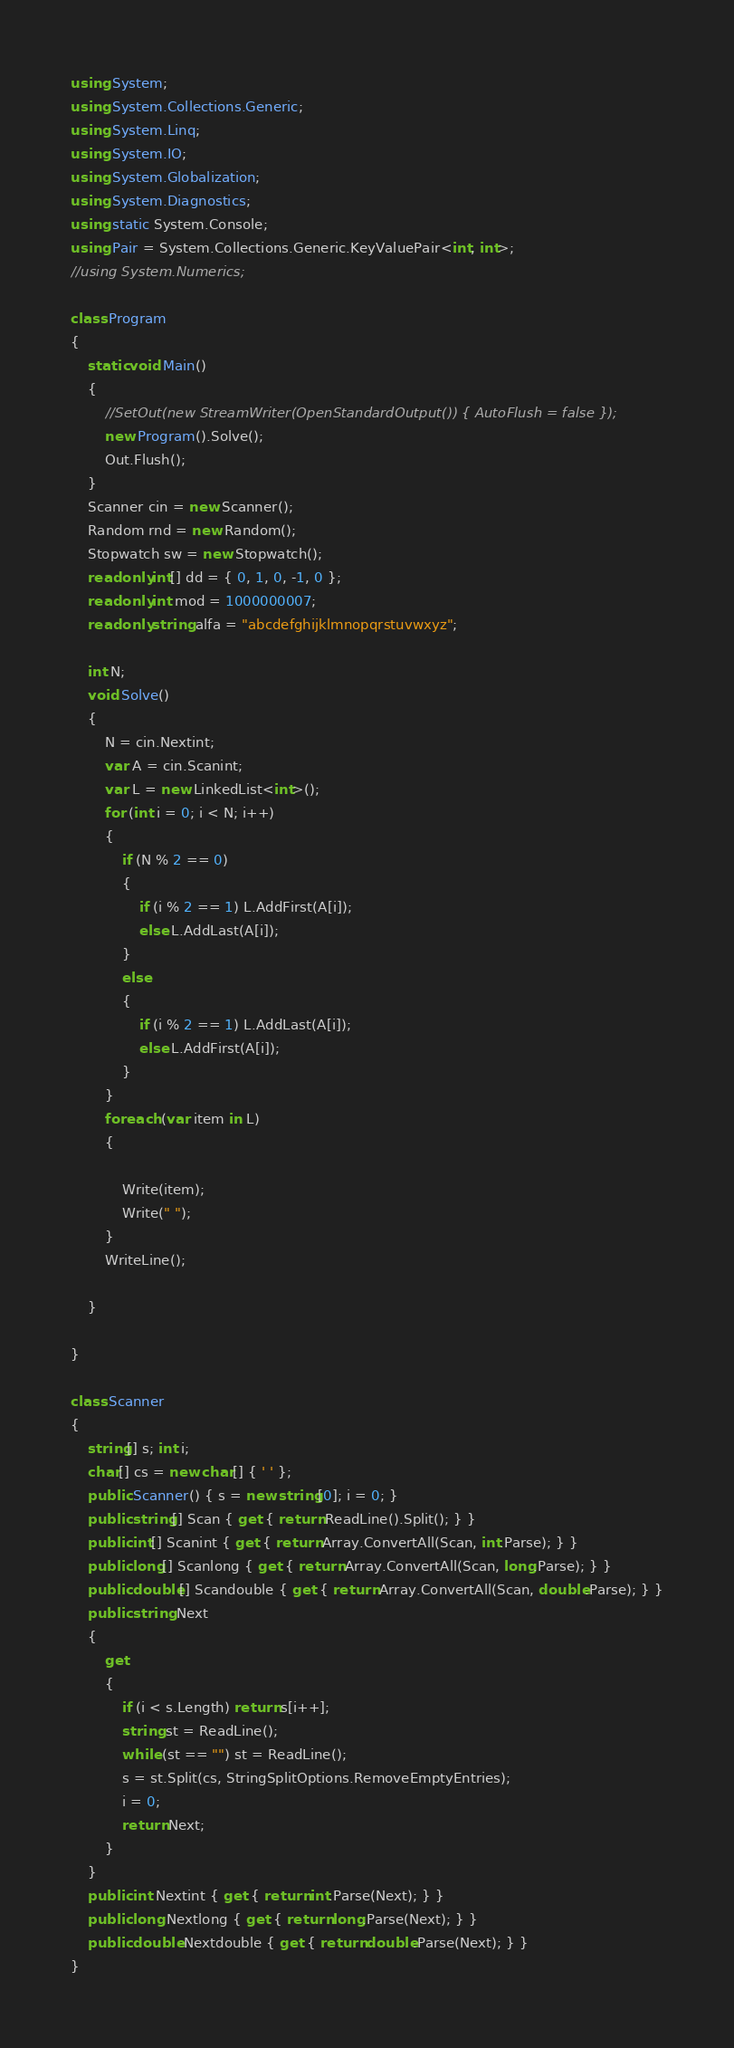Convert code to text. <code><loc_0><loc_0><loc_500><loc_500><_C#_>using System;
using System.Collections.Generic;
using System.Linq;
using System.IO;
using System.Globalization;
using System.Diagnostics;
using static System.Console;
using Pair = System.Collections.Generic.KeyValuePair<int, int>;
//using System.Numerics;

class Program
{
    static void Main()
    {
        //SetOut(new StreamWriter(OpenStandardOutput()) { AutoFlush = false });
        new Program().Solve();
        Out.Flush();
    }
    Scanner cin = new Scanner();
    Random rnd = new Random();
    Stopwatch sw = new Stopwatch();
    readonly int[] dd = { 0, 1, 0, -1, 0 };
    readonly int mod = 1000000007;
    readonly string alfa = "abcdefghijklmnopqrstuvwxyz";

    int N;
    void Solve()
    {
        N = cin.Nextint;
        var A = cin.Scanint;
        var L = new LinkedList<int>();
        for (int i = 0; i < N; i++)
        {
            if (N % 2 == 0)
            {
                if (i % 2 == 1) L.AddFirst(A[i]);
                else L.AddLast(A[i]);
            }
            else
            {
                if (i % 2 == 1) L.AddLast(A[i]);
                else L.AddFirst(A[i]);
            }
        }
        foreach (var item in L)
        {
           
            Write(item);
            Write(" ");
        }
        WriteLine();

    }

}

class Scanner
{
    string[] s; int i;
    char[] cs = new char[] { ' ' };
    public Scanner() { s = new string[0]; i = 0; }
    public string[] Scan { get { return ReadLine().Split(); } }
    public int[] Scanint { get { return Array.ConvertAll(Scan, int.Parse); } }
    public long[] Scanlong { get { return Array.ConvertAll(Scan, long.Parse); } }
    public double[] Scandouble { get { return Array.ConvertAll(Scan, double.Parse); } }
    public string Next
    {
        get
        {
            if (i < s.Length) return s[i++];
            string st = ReadLine();
            while (st == "") st = ReadLine();
            s = st.Split(cs, StringSplitOptions.RemoveEmptyEntries);
            i = 0;
            return Next;
        }
    }
    public int Nextint { get { return int.Parse(Next); } }
    public long Nextlong { get { return long.Parse(Next); } }
    public double Nextdouble { get { return double.Parse(Next); } }
}</code> 